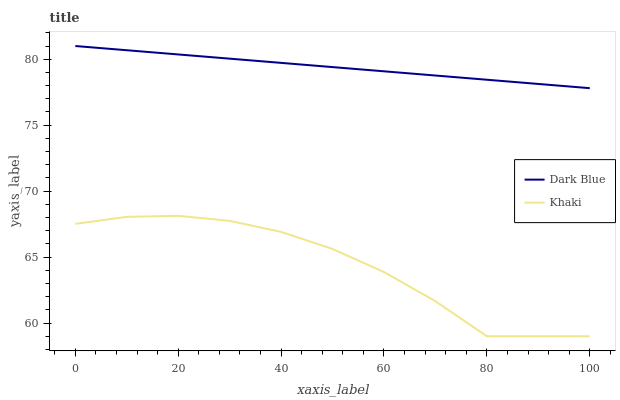Does Khaki have the minimum area under the curve?
Answer yes or no. Yes. Does Dark Blue have the maximum area under the curve?
Answer yes or no. Yes. Does Khaki have the maximum area under the curve?
Answer yes or no. No. Is Dark Blue the smoothest?
Answer yes or no. Yes. Is Khaki the roughest?
Answer yes or no. Yes. Is Khaki the smoothest?
Answer yes or no. No. Does Khaki have the lowest value?
Answer yes or no. Yes. Does Dark Blue have the highest value?
Answer yes or no. Yes. Does Khaki have the highest value?
Answer yes or no. No. Is Khaki less than Dark Blue?
Answer yes or no. Yes. Is Dark Blue greater than Khaki?
Answer yes or no. Yes. Does Khaki intersect Dark Blue?
Answer yes or no. No. 